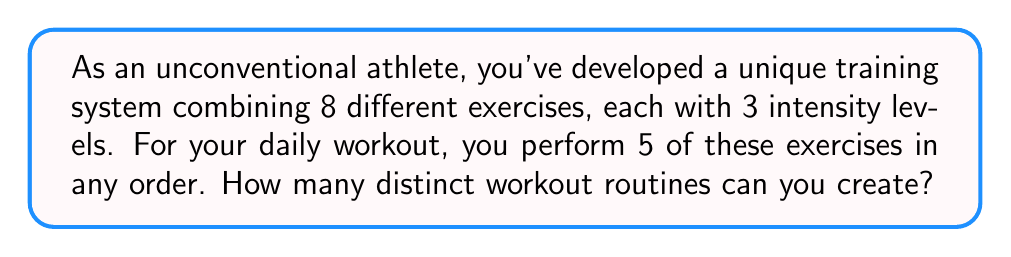Solve this math problem. Let's approach this step-by-step:

1) First, we need to choose 5 exercises out of 8. This is a combination problem, represented as $\binom{8}{5}$.

2) The number of combinations is calculated as:

   $$\binom{8}{5} = \frac{8!}{5!(8-5)!} = \frac{8!}{5!3!} = 56$$

3) For each of these 56 combinations, we need to consider the order of exercises, as changing the order creates a new routine. This is a permutation of 5 items, which is simply 5!:

   $$5! = 5 \times 4 \times 3 \times 2 \times 1 = 120$$

4) Now, for each exercise, we have 3 intensity levels to choose from. This gives us 3 choices for each of the 5 exercises in our routine. We can represent this as $3^5$:

   $$3^5 = 3 \times 3 \times 3 \times 3 \times 3 = 243$$

5) By the multiplication principle, the total number of unique workout routines is the product of these three factors:

   $$56 \times 120 \times 243 = 1,632,960$$

Therefore, you can create 1,632,960 distinct workout routines.
Answer: 1,632,960 